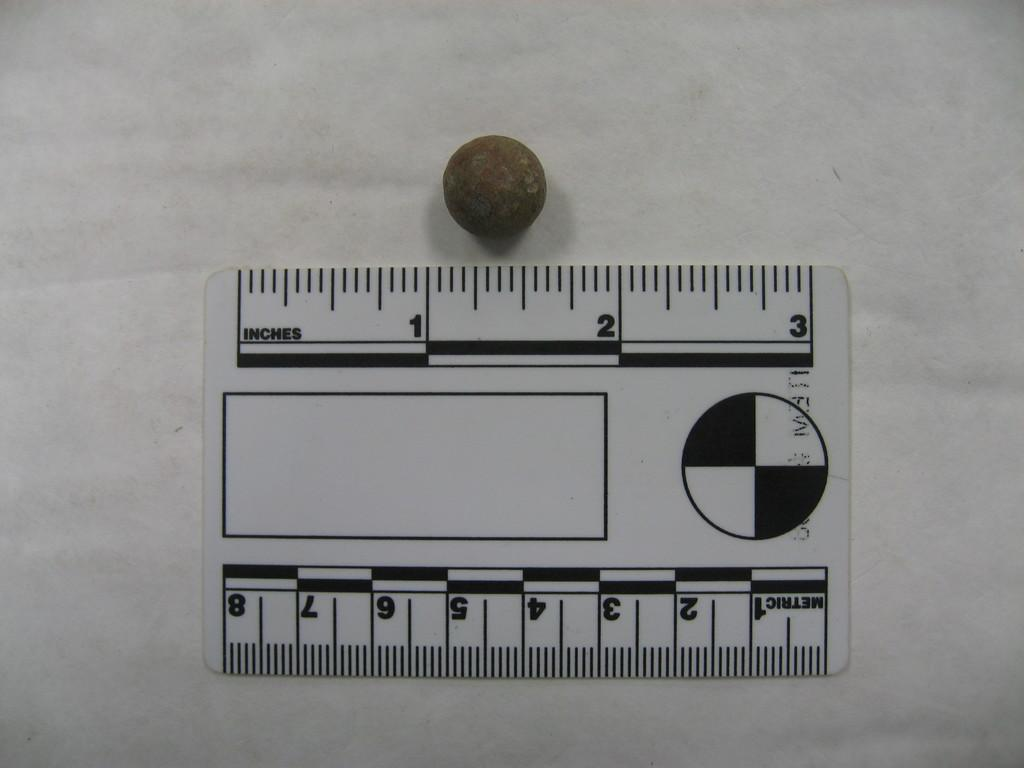<image>
Share a concise interpretation of the image provided. A ruler showing inches measurements for a small round object. 